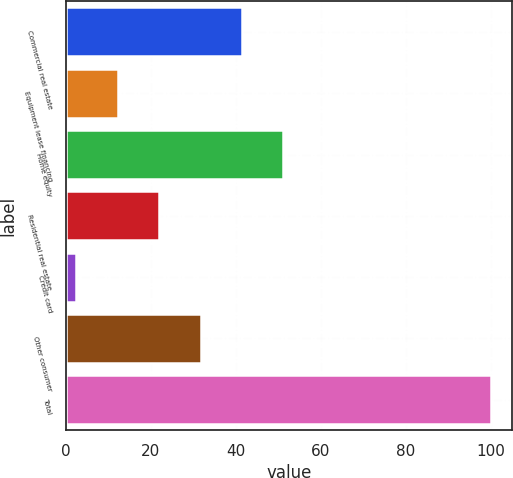<chart> <loc_0><loc_0><loc_500><loc_500><bar_chart><fcel>Commercial real estate<fcel>Equipment lease financing<fcel>Home equity<fcel>Residential real estate<fcel>Credit card<fcel>Other consumer<fcel>Total<nl><fcel>41.5<fcel>12.25<fcel>51.25<fcel>22<fcel>2.5<fcel>31.75<fcel>100<nl></chart> 